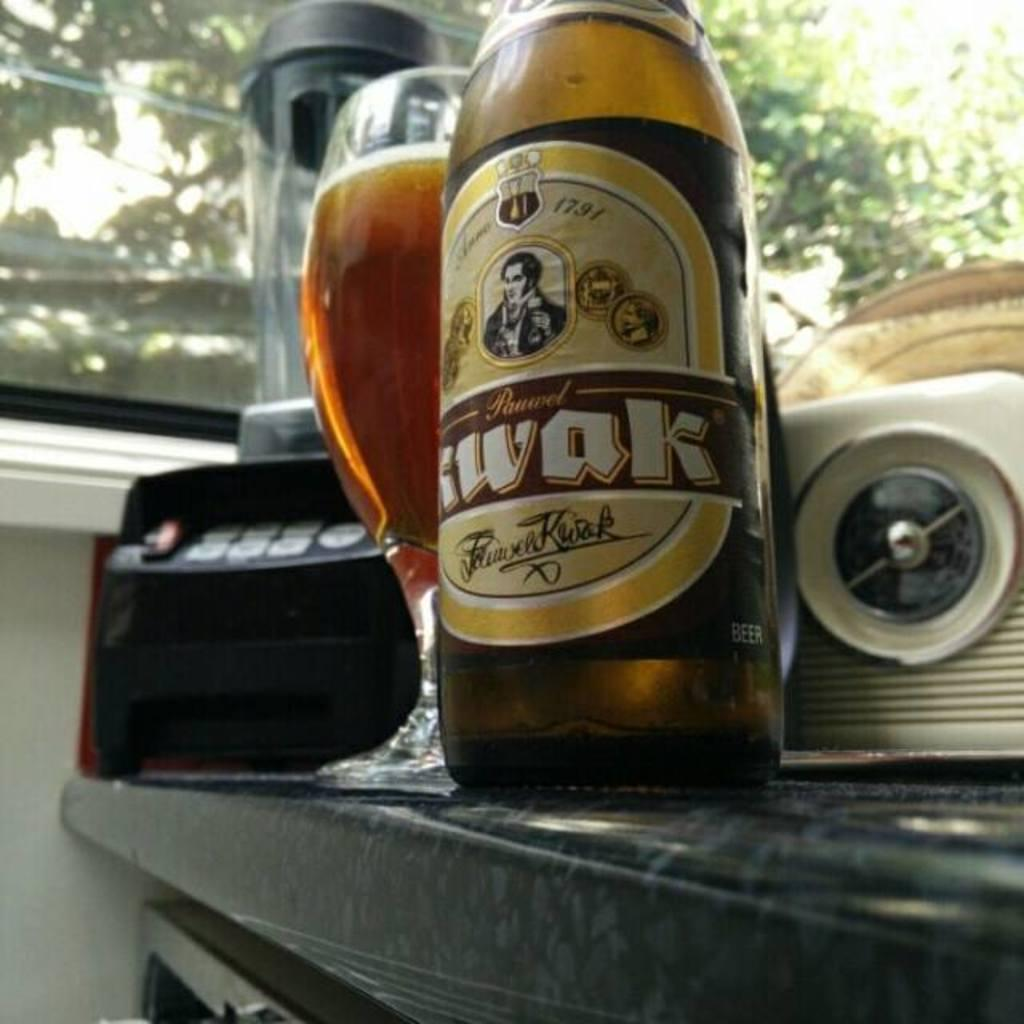What is the main subject of the image? The main subject of the image is a car. What objects are placed on the car? There is a wine glass and a bottle on the car. What can be seen in the background of the image? There is a car door and a tree visible in the background of the image. What is the historical significance of the mice in the image? There are no mice present in the image, so it is not possible to discuss their historical significance. 